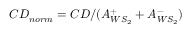<formula> <loc_0><loc_0><loc_500><loc_500>C D _ { n o r m } = C D / ( A _ { W S _ { 2 } } ^ { + } + A _ { W S _ { 2 } } ^ { - } )</formula> 